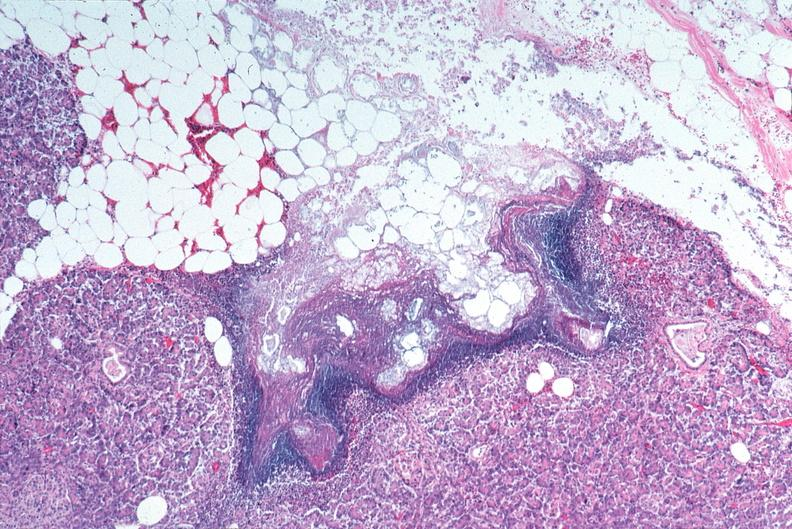does mixed mesodermal tumor show pancreatic fat necrosis?
Answer the question using a single word or phrase. No 